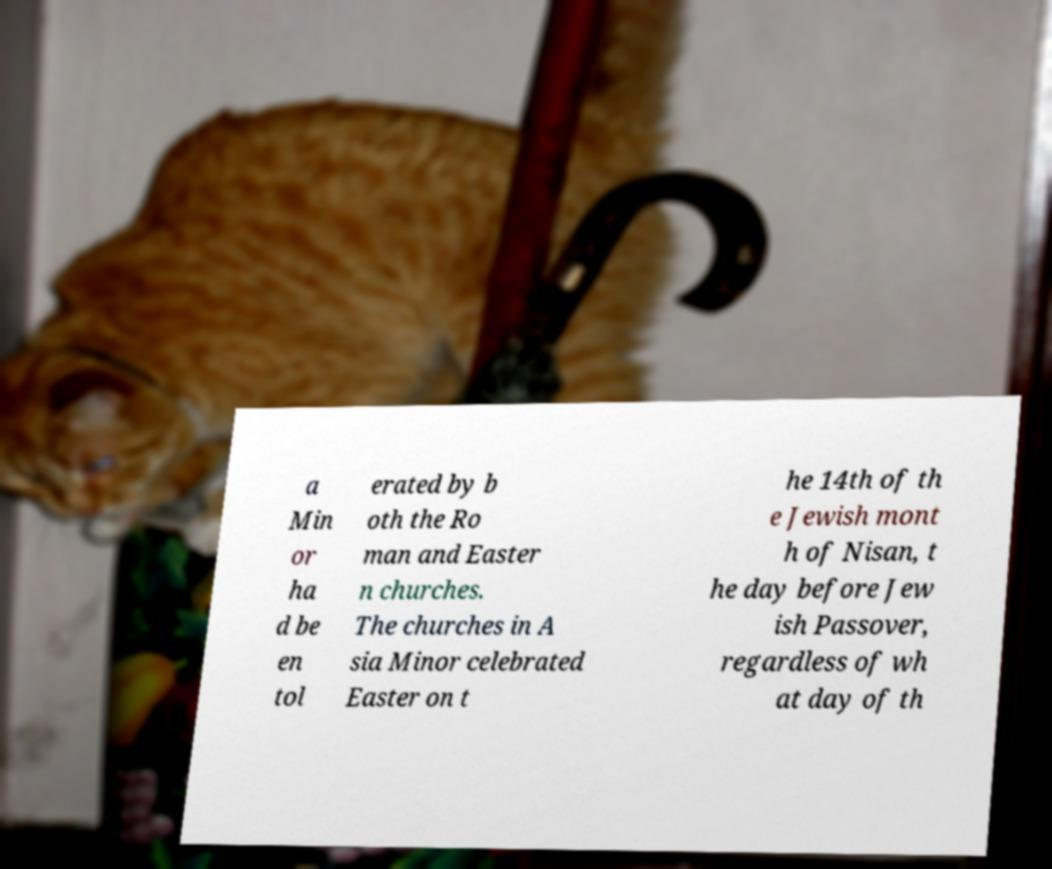Can you read and provide the text displayed in the image?This photo seems to have some interesting text. Can you extract and type it out for me? a Min or ha d be en tol erated by b oth the Ro man and Easter n churches. The churches in A sia Minor celebrated Easter on t he 14th of th e Jewish mont h of Nisan, t he day before Jew ish Passover, regardless of wh at day of th 